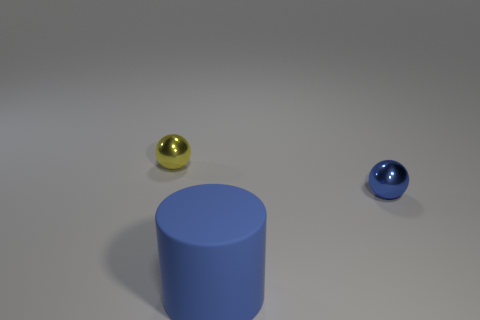Add 1 big cylinders. How many objects exist? 4 Subtract all cylinders. How many objects are left? 2 Add 3 big cylinders. How many big cylinders are left? 4 Add 3 tiny metal spheres. How many tiny metal spheres exist? 5 Subtract 0 red cubes. How many objects are left? 3 Subtract all tiny blue spheres. Subtract all small cyan cylinders. How many objects are left? 2 